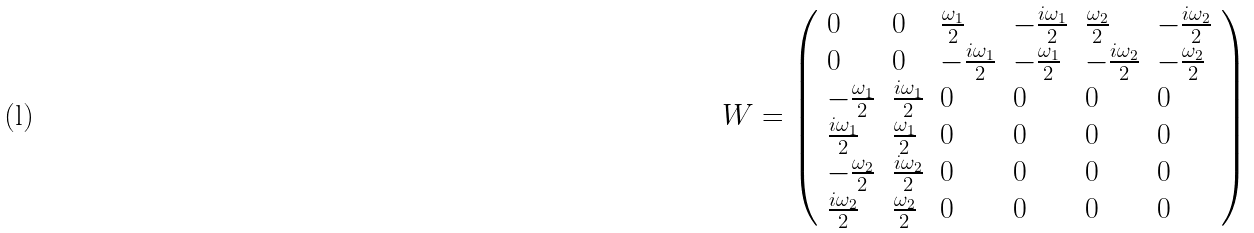<formula> <loc_0><loc_0><loc_500><loc_500>W = \left ( \begin{array} { l l l l l l } 0 & 0 & \frac { \omega _ { 1 } } { 2 } & - \frac { i \omega _ { 1 } } { 2 } & \frac { \omega _ { 2 } } { 2 } & - \frac { i \omega _ { 2 } } { 2 } \\ 0 & 0 & - \frac { i \omega _ { 1 } } { 2 } & - \frac { \omega _ { 1 } } { 2 } & - \frac { i \omega _ { 2 } } { 2 } & - \frac { \omega _ { 2 } } { 2 } \\ - \frac { \omega _ { 1 } } { 2 } & \frac { i \omega _ { 1 } } { 2 } & 0 & 0 & 0 & 0 \\ \frac { i \omega _ { 1 } } { 2 } & \frac { \omega _ { 1 } } { 2 } & 0 & 0 & 0 & 0 \\ - \frac { \omega _ { 2 } } { 2 } & \frac { i \omega _ { 2 } } { 2 } & 0 & 0 & 0 & 0 \\ \frac { i \omega _ { 2 } } { 2 } & \frac { \omega _ { 2 } } { 2 } & 0 & 0 & 0 & 0 \end{array} \right )</formula> 